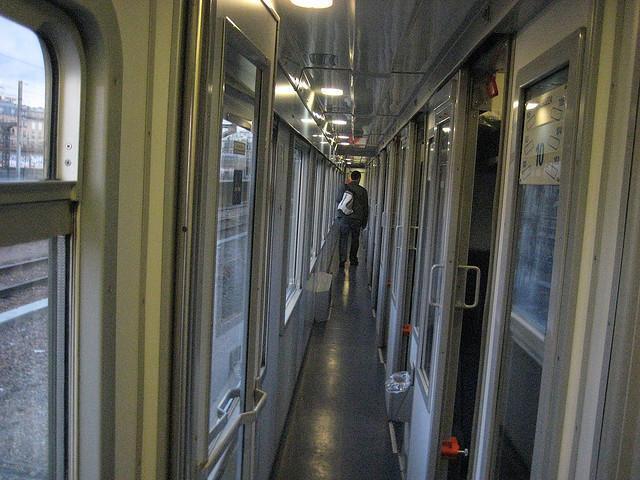How many people are in this scene?
Give a very brief answer. 1. How many giraffes are in the scene?
Give a very brief answer. 0. 